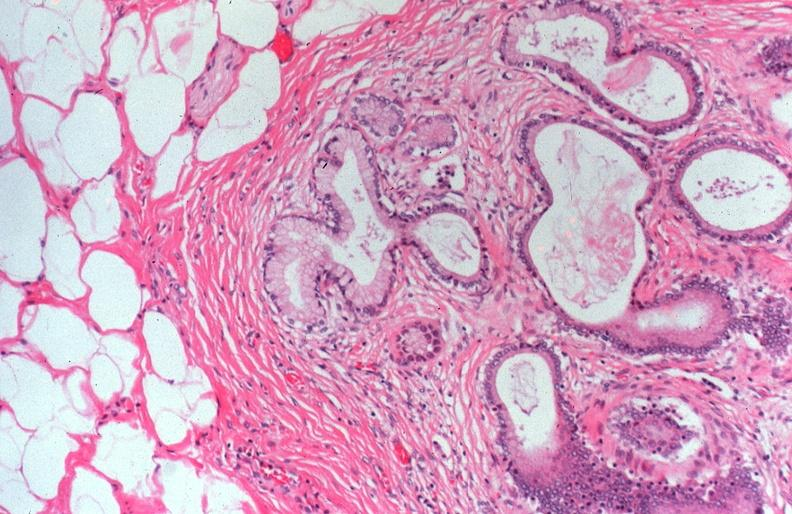what is present?
Answer the question using a single word or phrase. Pancreas 